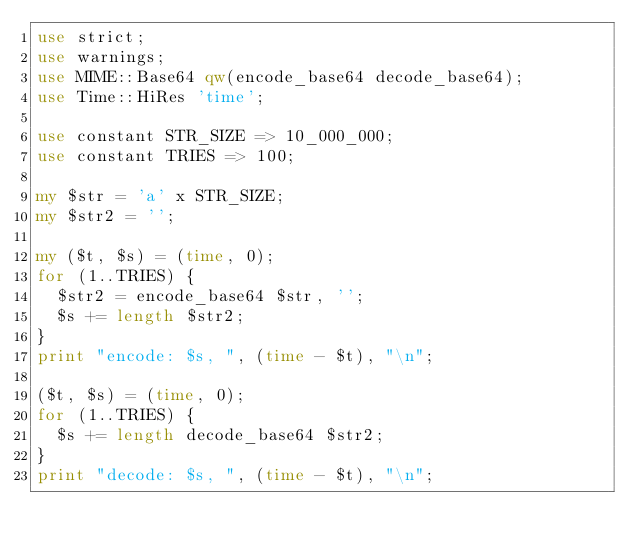Convert code to text. <code><loc_0><loc_0><loc_500><loc_500><_Perl_>use strict;
use warnings;
use MIME::Base64 qw(encode_base64 decode_base64);
use Time::HiRes 'time';

use constant STR_SIZE => 10_000_000;
use constant TRIES => 100;

my $str = 'a' x STR_SIZE;
my $str2 = '';

my ($t, $s) = (time, 0);
for (1..TRIES) {
  $str2 = encode_base64 $str, '';
  $s += length $str2;
}
print "encode: $s, ", (time - $t), "\n";

($t, $s) = (time, 0);
for (1..TRIES) {
  $s += length decode_base64 $str2;
}
print "decode: $s, ", (time - $t), "\n";
</code> 